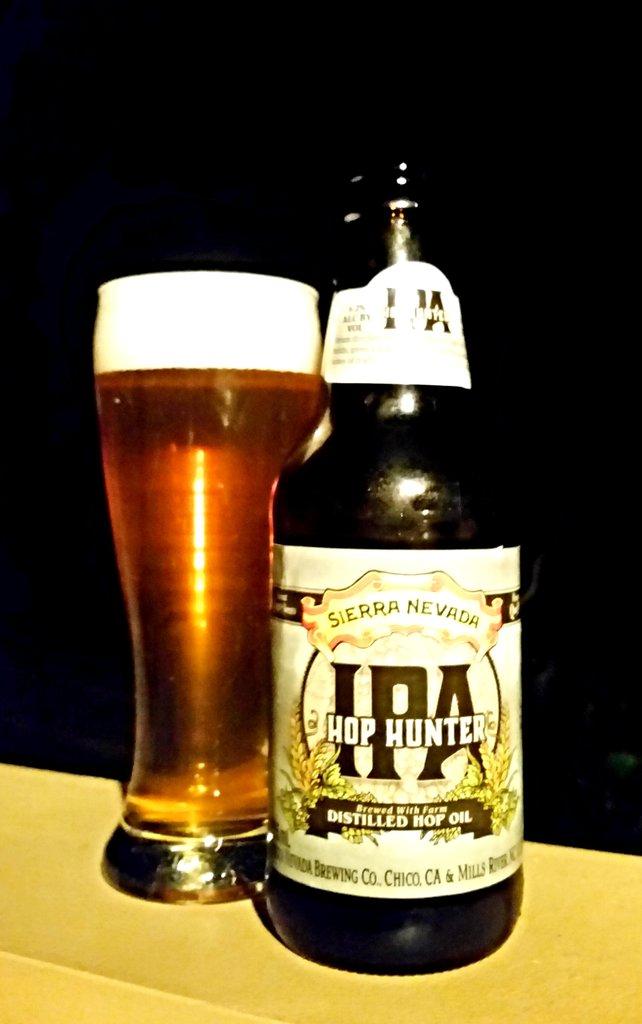What kind of beer is this?
Your response must be concise. Ipa. What brand of beer is it?
Ensure brevity in your answer.  Ipa hop hunter. 